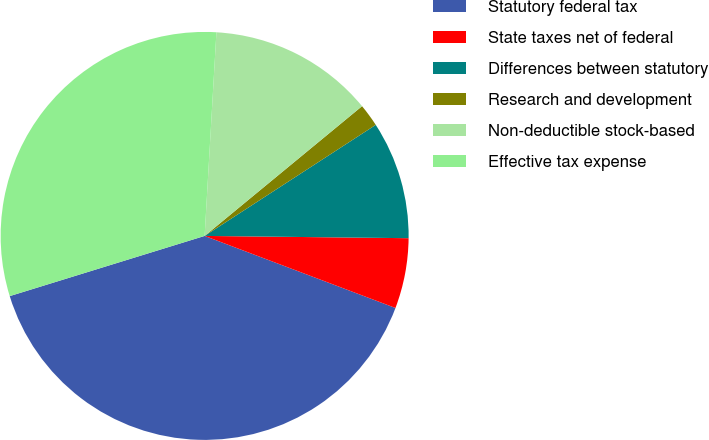Convert chart. <chart><loc_0><loc_0><loc_500><loc_500><pie_chart><fcel>Statutory federal tax<fcel>State taxes net of federal<fcel>Differences between statutory<fcel>Research and development<fcel>Non-deductible stock-based<fcel>Effective tax expense<nl><fcel>39.49%<fcel>5.57%<fcel>9.34%<fcel>1.81%<fcel>13.11%<fcel>30.69%<nl></chart> 